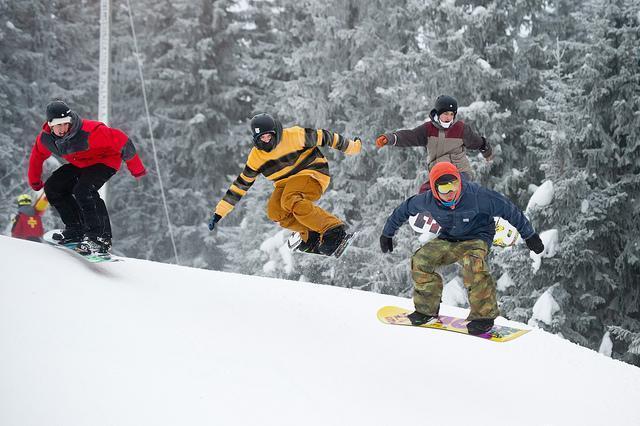How many people are jumping?
Give a very brief answer. 2. How many people are there?
Give a very brief answer. 4. How many umbrellas are visible?
Give a very brief answer. 0. 